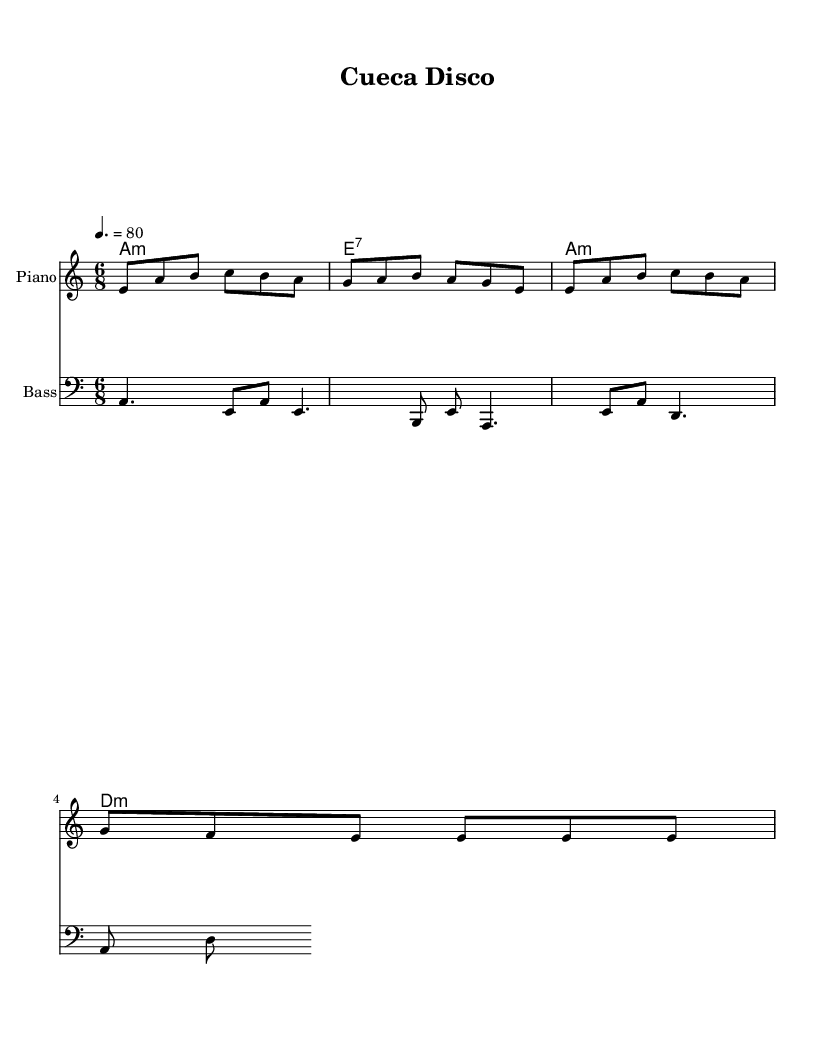What is the key signature of this music? The key signature shows the note A minor with no sharps or flats. It is represented at the beginning of the score, indicating the tonal center of the piece.
Answer: A minor What is the time signature of this music? The time signature is displayed as 6/8, indicating that there are six eighth-note beats in each measure. This can be found at the beginning of the score, which gives insight into the rhythmic feel of the piece.
Answer: 6/8 What is the tempo marking for this piece? The tempo marking indicates a speed of 80 beats per minute, and it appears above the staff at the beginning of the score, guiding the performer on how fast to play the piece.
Answer: 80 What is the primary chord used in the melody? The primary chord emphasized throughout the piece is A minor, which is indicated in the chord names section and aligns with the first three measures of the melody featuring the A note prominently.
Answer: A minor How many measures are in this score? The score consists of four unique measures, which can be counted directly from the melody and harmony lines, making it clear that the piece is structured around these musical phrases.
Answer: 4 What is the clef used for the bass line? The bass line is written in the bass clef, which is visually indicated at the beginning of the bass staff, allowing performers to read lower pitch notes.
Answer: Bass clef Which instrument is indicated for the melody line? The melody line is indicated for the piano in the instrumental name at the top of the staff, clarifying which instrument should perform this melodic part.
Answer: Piano 